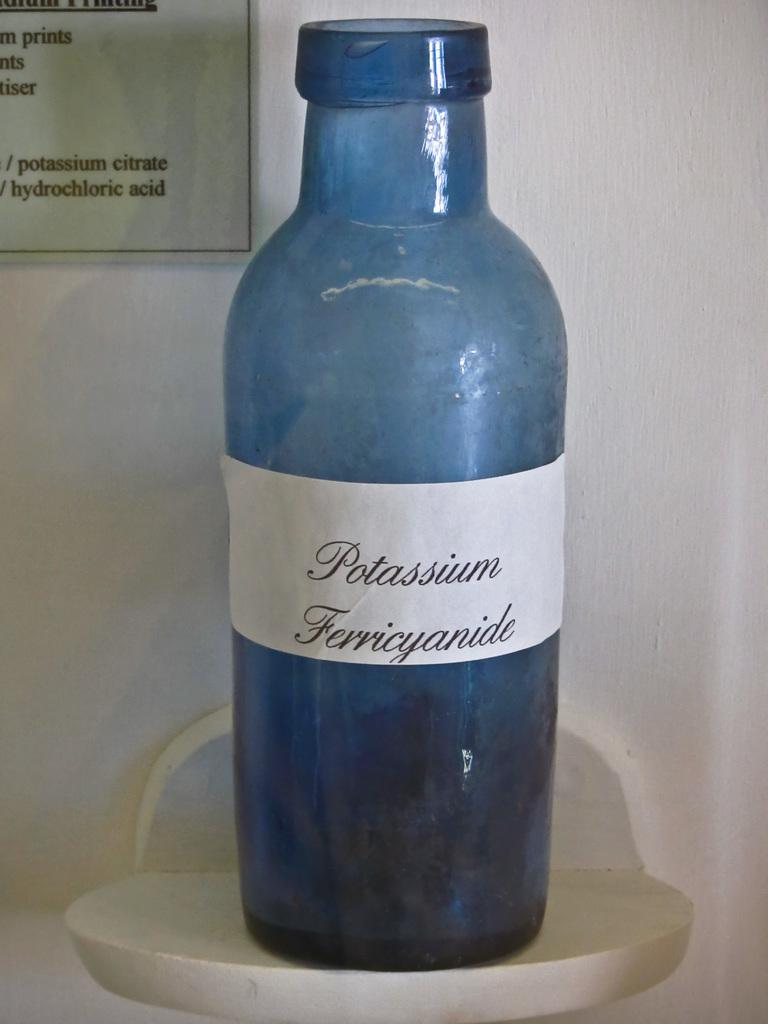What is the first word on the bottle?
Provide a short and direct response. Potassium. What is the second word on the bottle?
Provide a succinct answer. Ferricyanide. 